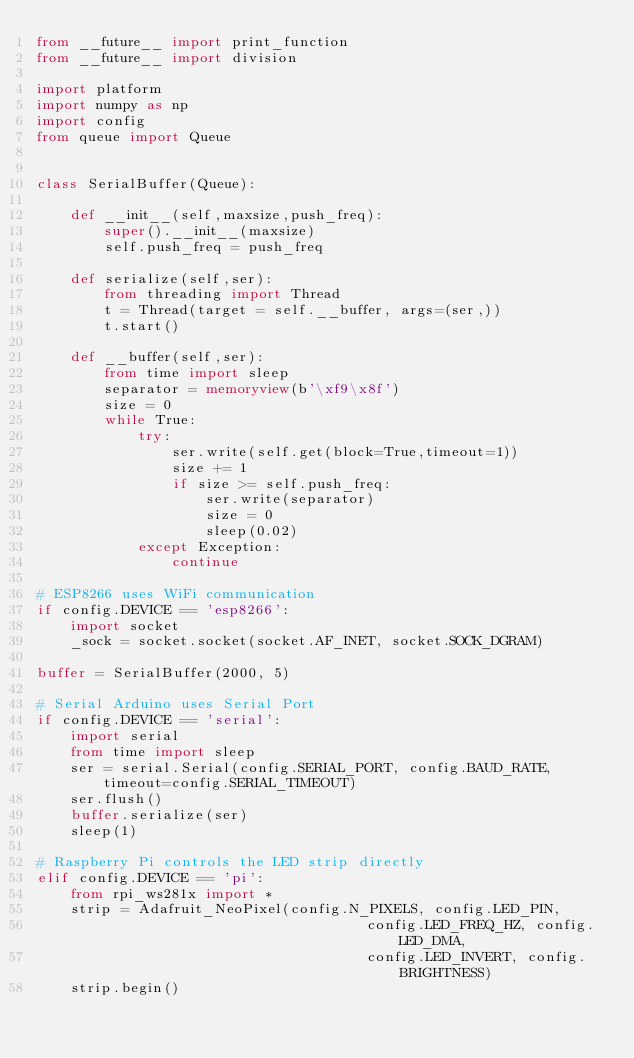<code> <loc_0><loc_0><loc_500><loc_500><_Python_>from __future__ import print_function
from __future__ import division

import platform
import numpy as np
import config
from queue import Queue


class SerialBuffer(Queue):

    def __init__(self,maxsize,push_freq):
        super().__init__(maxsize)
        self.push_freq = push_freq
    
    def serialize(self,ser):
        from threading import Thread 
        t = Thread(target = self.__buffer, args=(ser,))
        t.start()

    def __buffer(self,ser):
        from time import sleep
        separator = memoryview(b'\xf9\x8f')
        size = 0
        while True:
            try:
                ser.write(self.get(block=True,timeout=1))
                size += 1
                if size >= self.push_freq:
                    ser.write(separator)
                    size = 0
                    sleep(0.02)
            except Exception:
                continue

# ESP8266 uses WiFi communication
if config.DEVICE == 'esp8266':
    import socket
    _sock = socket.socket(socket.AF_INET, socket.SOCK_DGRAM)

buffer = SerialBuffer(2000, 5)

# Serial Arduino uses Serial Port
if config.DEVICE == 'serial':
    import serial
    from time import sleep
    ser = serial.Serial(config.SERIAL_PORT, config.BAUD_RATE, timeout=config.SERIAL_TIMEOUT)
    ser.flush()
    buffer.serialize(ser)
    sleep(1)

# Raspberry Pi controls the LED strip directly
elif config.DEVICE == 'pi':
    from rpi_ws281x import *
    strip = Adafruit_NeoPixel(config.N_PIXELS, config.LED_PIN,
                                       config.LED_FREQ_HZ, config.LED_DMA,
                                       config.LED_INVERT, config.BRIGHTNESS)
    strip.begin()</code> 